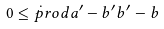Convert formula to latex. <formula><loc_0><loc_0><loc_500><loc_500>0 \leq \dot { p } r o d { a ^ { \prime } - b ^ { \prime } } { b ^ { \prime } - b }</formula> 